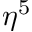<formula> <loc_0><loc_0><loc_500><loc_500>\eta ^ { 5 }</formula> 